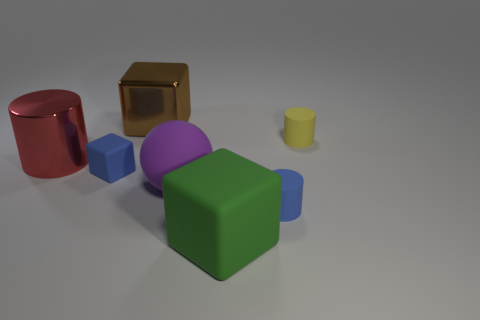Add 2 small blue cubes. How many objects exist? 9 Subtract all balls. How many objects are left? 6 Add 7 big spheres. How many big spheres exist? 8 Subtract 0 red blocks. How many objects are left? 7 Subtract all green metallic blocks. Subtract all green blocks. How many objects are left? 6 Add 7 big brown shiny things. How many big brown shiny things are left? 8 